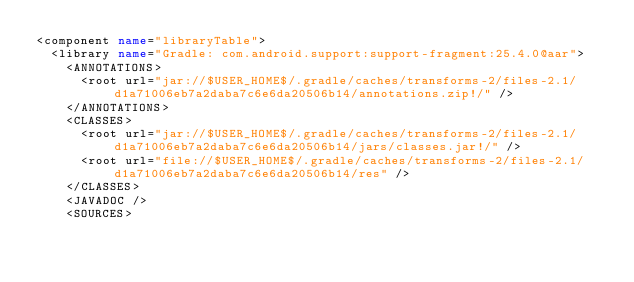<code> <loc_0><loc_0><loc_500><loc_500><_XML_><component name="libraryTable">
  <library name="Gradle: com.android.support:support-fragment:25.4.0@aar">
    <ANNOTATIONS>
      <root url="jar://$USER_HOME$/.gradle/caches/transforms-2/files-2.1/d1a71006eb7a2daba7c6e6da20506b14/annotations.zip!/" />
    </ANNOTATIONS>
    <CLASSES>
      <root url="jar://$USER_HOME$/.gradle/caches/transforms-2/files-2.1/d1a71006eb7a2daba7c6e6da20506b14/jars/classes.jar!/" />
      <root url="file://$USER_HOME$/.gradle/caches/transforms-2/files-2.1/d1a71006eb7a2daba7c6e6da20506b14/res" />
    </CLASSES>
    <JAVADOC />
    <SOURCES></code> 